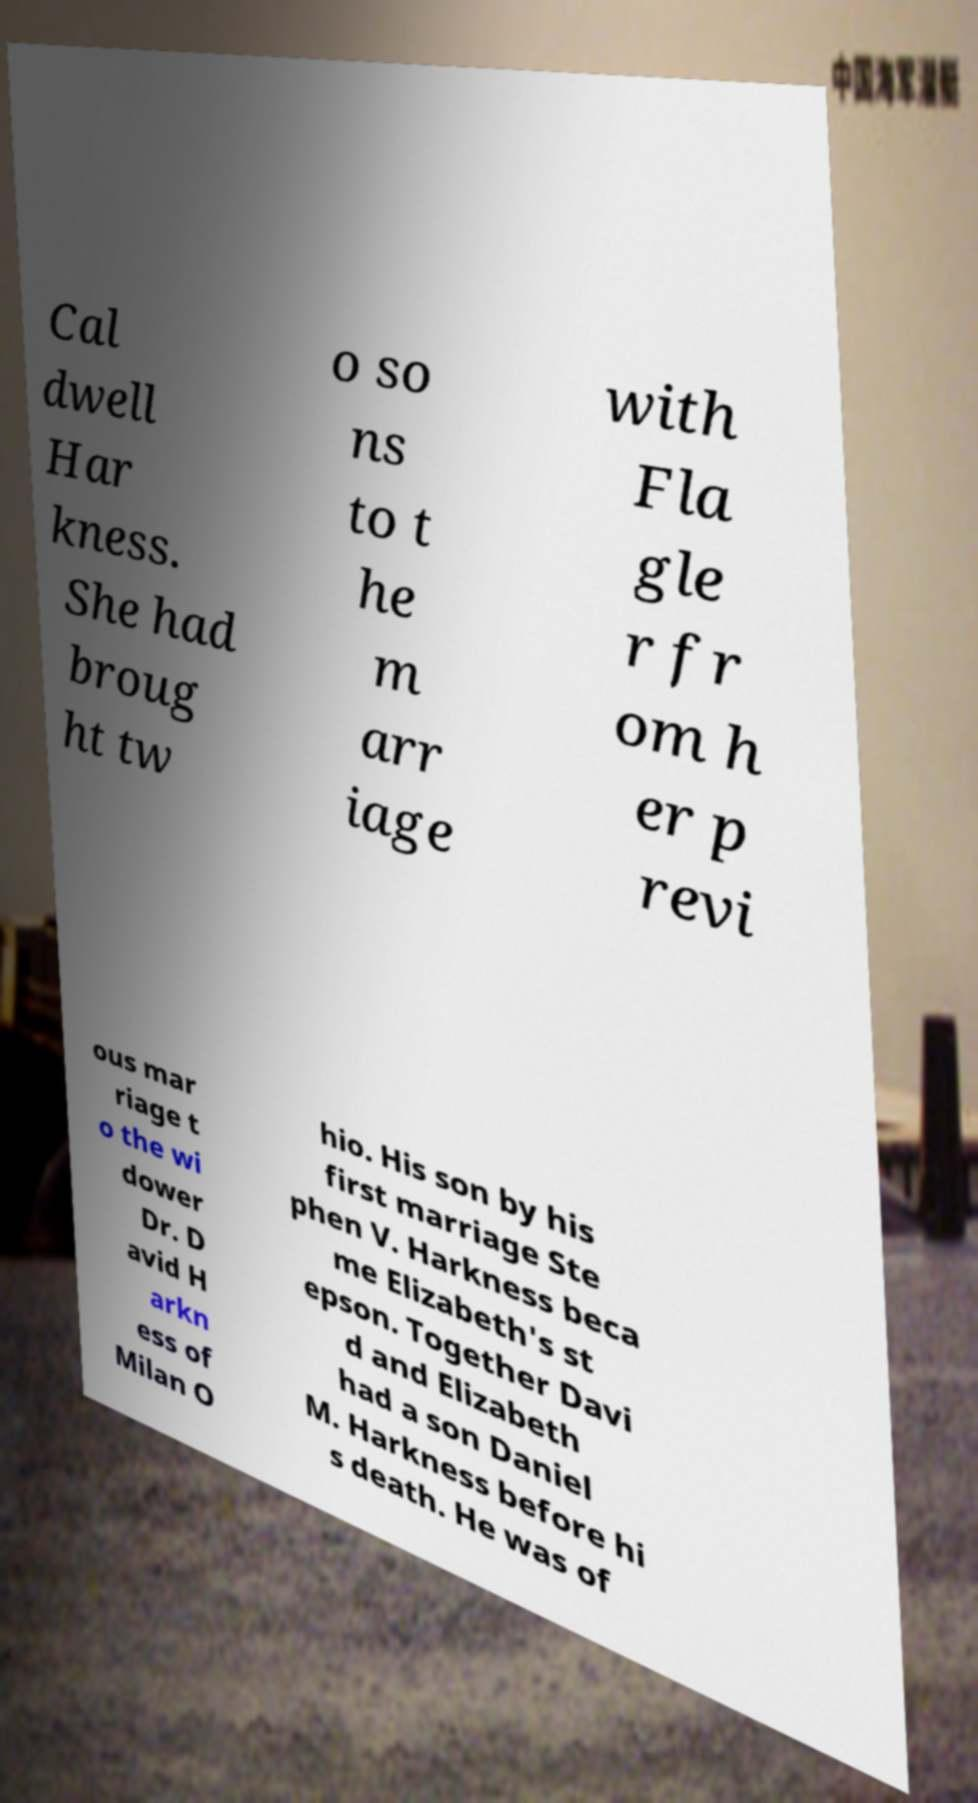Please identify and transcribe the text found in this image. Cal dwell Har kness. She had broug ht tw o so ns to t he m arr iage with Fla gle r fr om h er p revi ous mar riage t o the wi dower Dr. D avid H arkn ess of Milan O hio. His son by his first marriage Ste phen V. Harkness beca me Elizabeth's st epson. Together Davi d and Elizabeth had a son Daniel M. Harkness before hi s death. He was of 